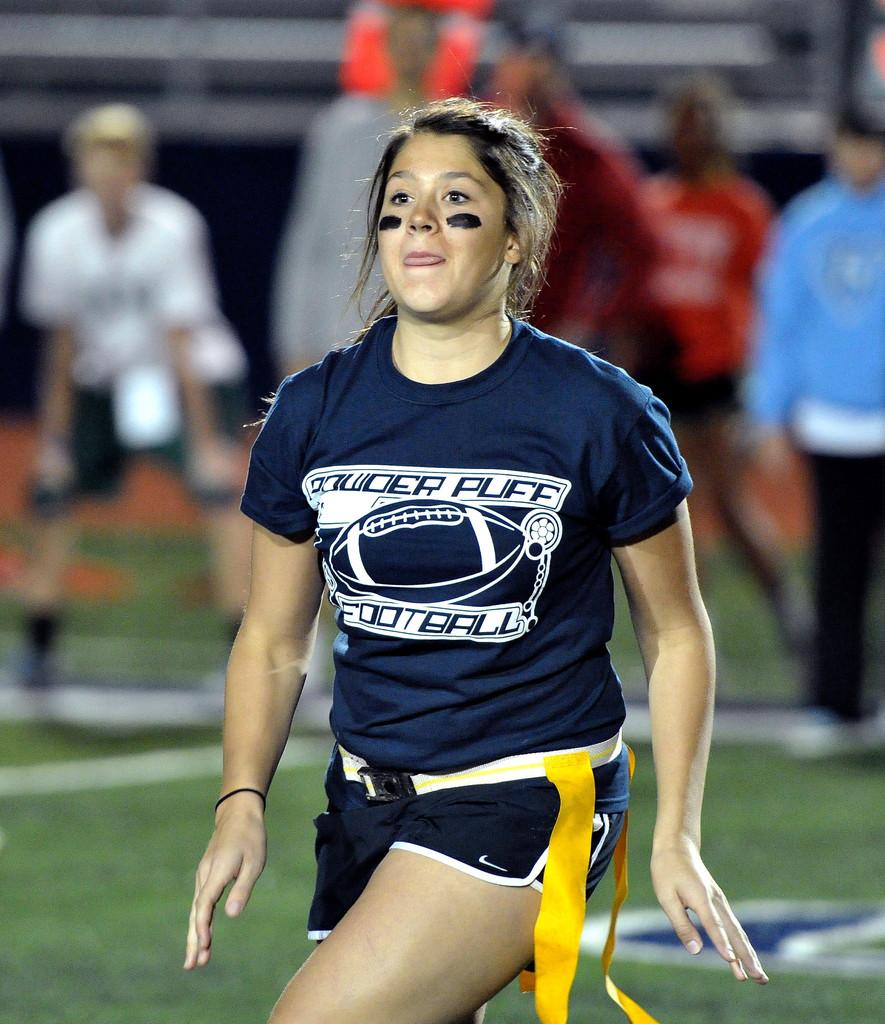Provide a one-sentence caption for the provided image. A female player on the Powder Puff football team in uniform on the playing field near a sideline where people stand.. 